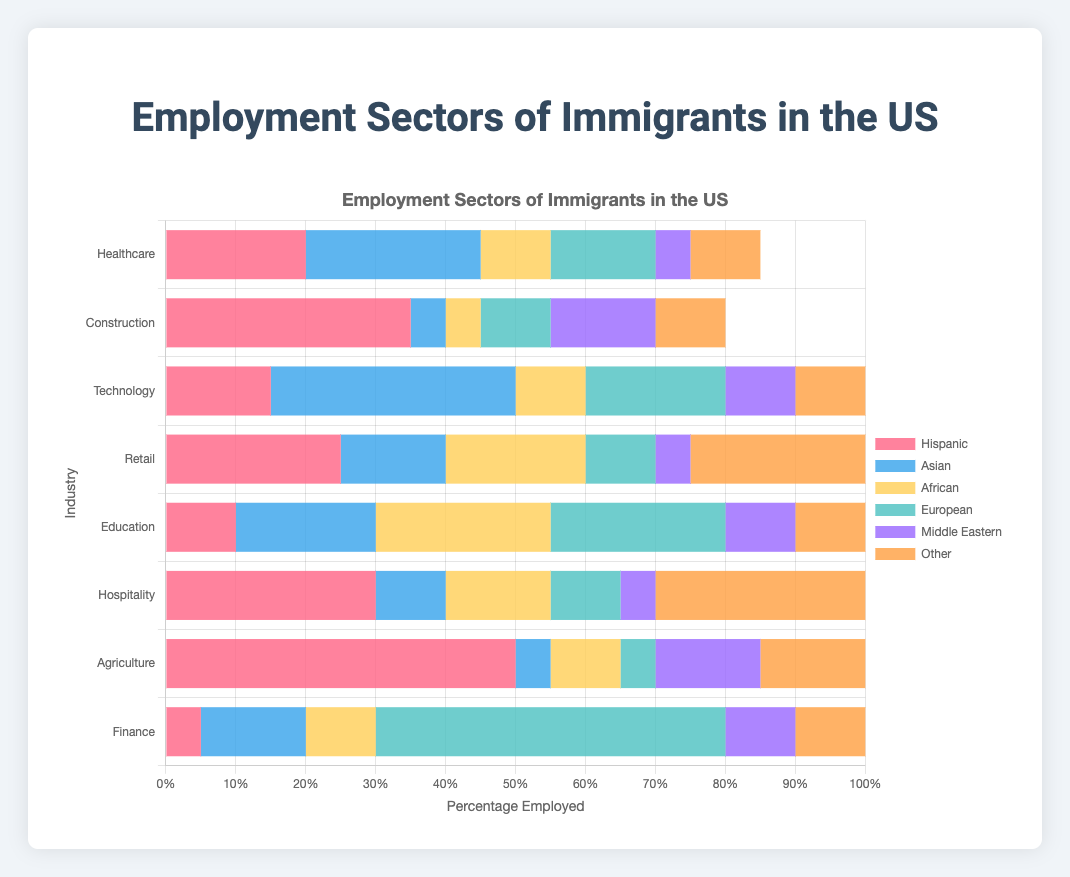Which industry employs the highest percentage of Hispanic immigrants? Looking at the figure, the Healthcare industry shows Hispanic employment at 20%, which is lower than Construction (35%), Retail (25%), Hospitality (30%), and Agriculture (50%). The highest is Agriculture.
Answer: Agriculture Which group has the largest percentage in Finance? The largest percentage in the Finance sector is European immigrants at 50%, as indicated by the longest bar segment under Finance.
Answer: European Which industry has the smallest percentage of employment for Middle Eastern immigrants? The smallest percentage employment for Middle Eastern immigrants is Healthcare (5%), verified by comparing all industry bars for the smallest segment for Middle Eastern.
Answer: Healthcare In which industry do Asian immigrants have a greater percentage of employment than Hispanic immigrants? Asian immigrants have a greater employment percentage than Hispanic immigrants in Healthcare (25% vs. 20%) and Technology (35% vs. 15%), as seen by longer bar segments for Asians in these sectors.
Answer: Healthcare and Technology What is the combined percentage of African immigrants in Healthcare, Education, and Hospitality? Adding up African employment percentages: Healthcare (10%) + Education (25%) + Hospitality (15%) = 10 + 25 + 15 = 50%.
Answer: 50% Which immigrant group has equal percentages in more than one industry, and what are those industries? The Other group has equal employment percentages (10%) in Technology, Healthcare, Construction, Education, and Finance, as indicated by similarly long bar segments for these sectors.
Answer: Other group; Technology, Healthcare, Construction, Education, and Finance What is the percentage difference between Hispanic and European employment in the Technology sector? Hispanic employment in Technology is 15%, and European is 20%; the difference is 20% - 15% = 5%.
Answer: 5% How many sectors have the Hispanic group's employment percentage strictly greater than 25%? Sectors are Construction (35%), Retail (25%), Hospitality (30%), and Agriculture (50%). Only Construction, Hospitality, and Agriculture have values strictly greater.
Answer: 3 What is the second largest employment percentage for the European group across all industries? The largest is Finance at 50%, and the second-largest is Education (25%) by scanning bars labeled European.
Answer: 25% 